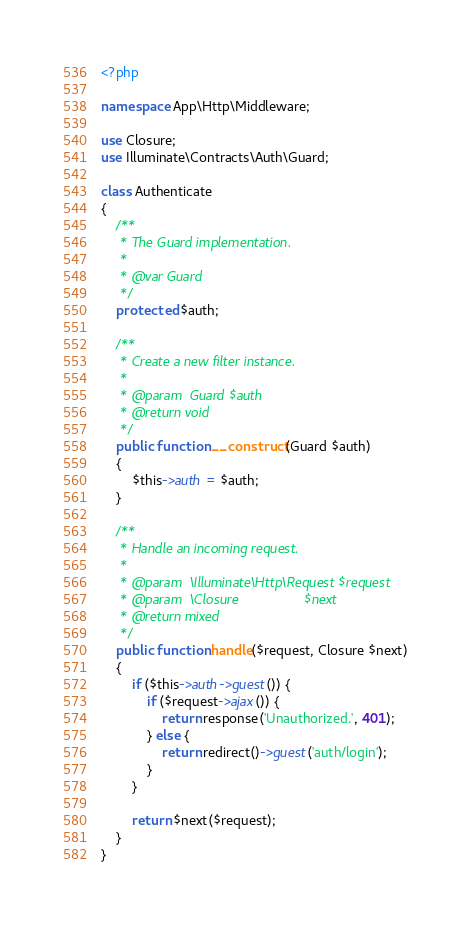<code> <loc_0><loc_0><loc_500><loc_500><_PHP_><?php

namespace App\Http\Middleware;

use Closure;
use Illuminate\Contracts\Auth\Guard;

class Authenticate
{
    /**
     * The Guard implementation.
     *
     * @var Guard
     */
    protected $auth;

    /**
     * Create a new filter instance.
     *
     * @param  Guard $auth
     * @return void
     */
    public function __construct(Guard $auth)
    {
        $this->auth = $auth;
    }

    /**
     * Handle an incoming request.
     *
     * @param  \Illuminate\Http\Request $request
     * @param  \Closure                 $next
     * @return mixed
     */
    public function handle($request, Closure $next)
    {
        if ($this->auth->guest()) {
            if ($request->ajax()) {
                return response('Unauthorized.', 401);
            } else {
                return redirect()->guest('auth/login');
            }
        }

        return $next($request);
    }
}
</code> 